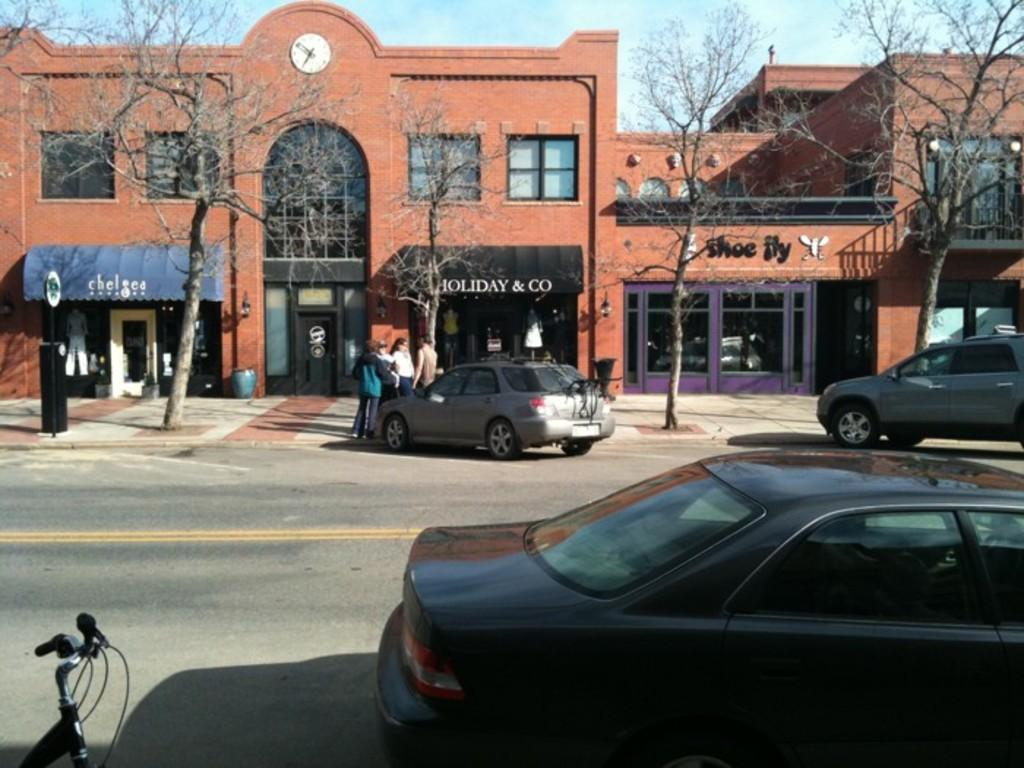What type of natural elements can be seen in the image? There are trees in the image. What type of man-made structure is present in the image? There is a building in the image. Are there any people visible in the image? Yes, there are people in the image. What type of informational signage is present in the image? There is a signboard in the image. What type of transportation can be seen in the image? There are vehicles in the image. What part of the natural environment is visible in the image? The sky is visible in the background of the image. What type of timekeeping device is present on the building? There is a clock on the building. Can you tell me what type of argument is taking place between the trees in the image? There is no argument taking place between the trees in the image, as trees do not engage in arguments. What type of love is being expressed by the vehicles in the image? There is no love being expressed by the vehicles in the image, as vehicles do not have the ability to express emotions. 